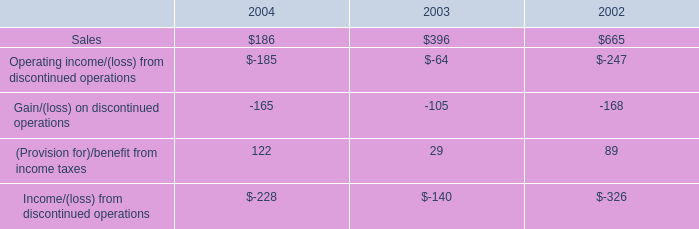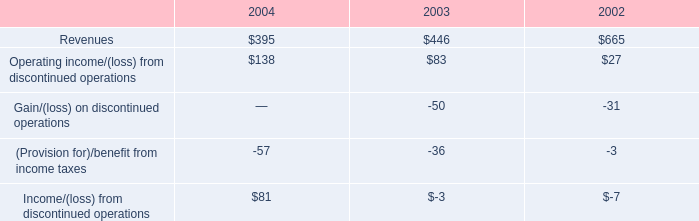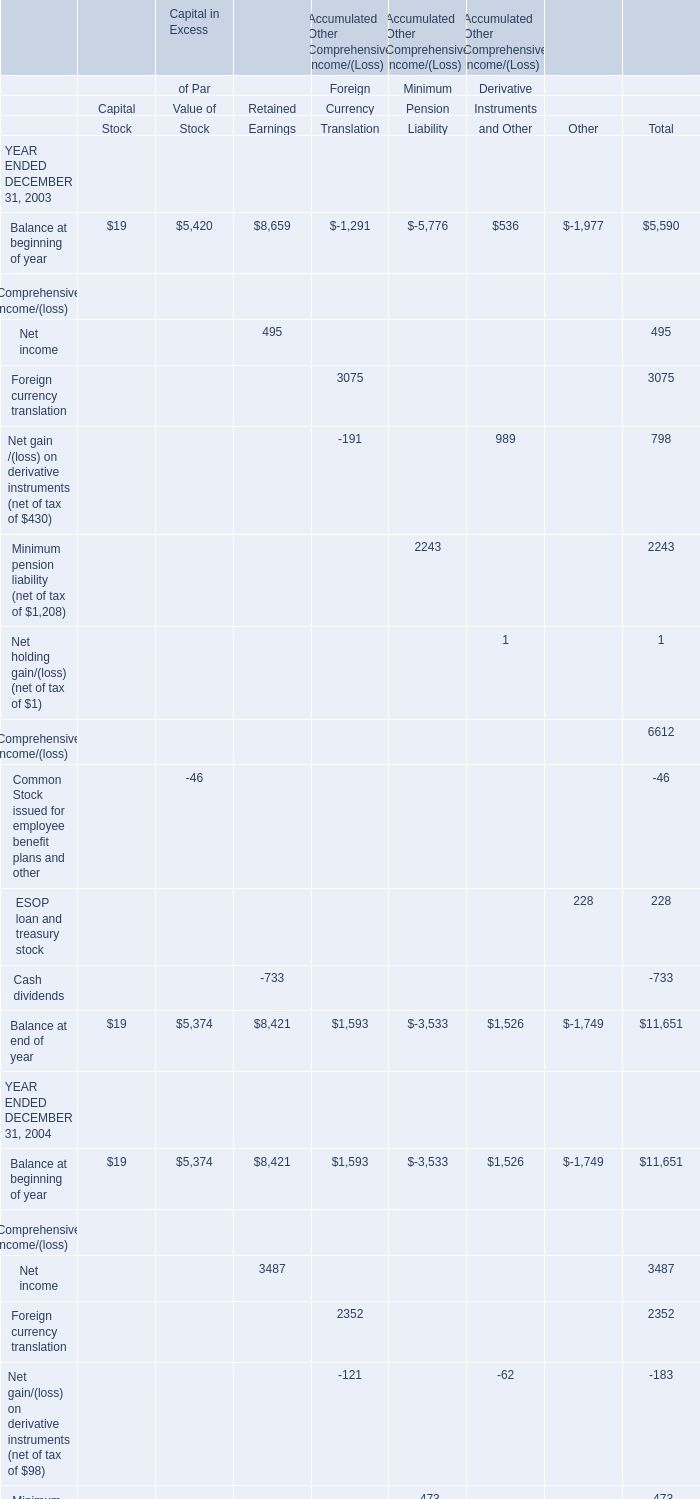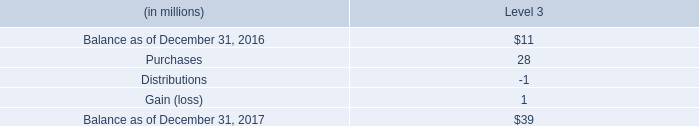what was the ratio of the pension trust assets for 2017 to 2016 $ 1739 million and $ 1632 
Computations: (1739 / 1632)
Answer: 1.06556. 